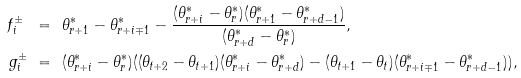Convert formula to latex. <formula><loc_0><loc_0><loc_500><loc_500>f ^ { \pm } _ { i } \ & = \ \theta ^ { * } _ { r + 1 } - \theta ^ { * } _ { r + i \mp 1 } - \frac { ( \theta ^ { * } _ { r + i } - \theta ^ { * } _ { r } ) ( \theta ^ { * } _ { r + 1 } - \theta ^ { * } _ { r + d - 1 } ) } { ( \theta ^ { * } _ { r + d } - \theta ^ { * } _ { r } ) } , \\ g ^ { \pm } _ { i } \ & = \ ( \theta ^ { * } _ { r + i } - \theta ^ { * } _ { r } ) ( ( \theta _ { t + 2 } - \theta _ { t + 1 } ) ( \theta ^ { * } _ { r + i } - \theta ^ { * } _ { r + d } ) - ( \theta _ { t + 1 } - \theta _ { t } ) ( \theta ^ { * } _ { r + i \mp 1 } - \theta ^ { * } _ { r + d - 1 } ) ) ,</formula> 